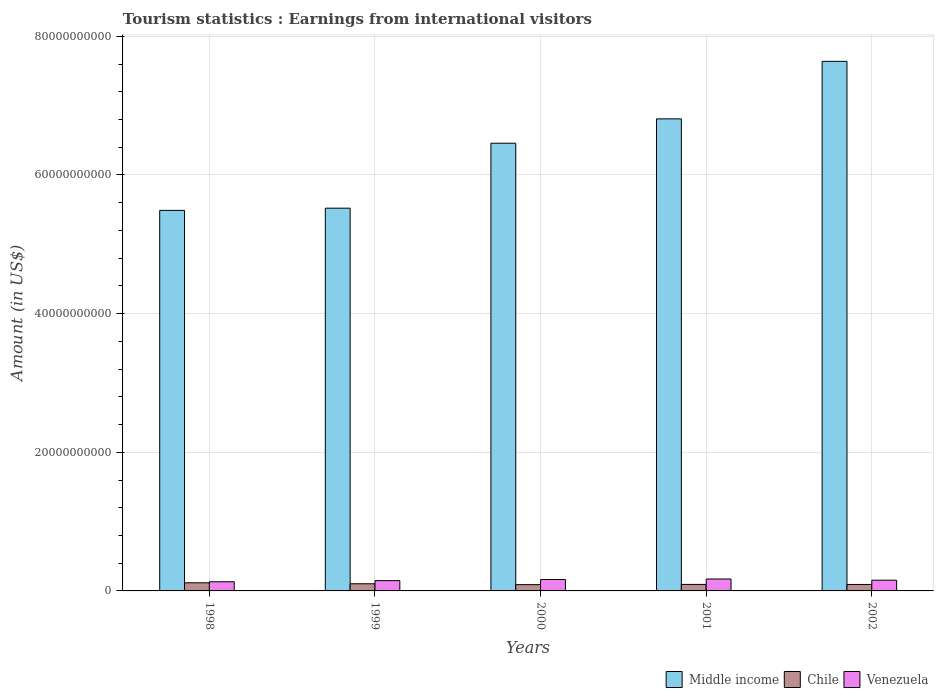How many different coloured bars are there?
Your answer should be compact. 3. How many groups of bars are there?
Offer a very short reply. 5. What is the label of the 5th group of bars from the left?
Offer a very short reply. 2002. What is the earnings from international visitors in Chile in 1999?
Your answer should be very brief. 1.03e+09. Across all years, what is the maximum earnings from international visitors in Middle income?
Your answer should be very brief. 7.64e+1. Across all years, what is the minimum earnings from international visitors in Middle income?
Your answer should be very brief. 5.49e+1. In which year was the earnings from international visitors in Venezuela maximum?
Provide a succinct answer. 2001. What is the total earnings from international visitors in Middle income in the graph?
Provide a short and direct response. 3.19e+11. What is the difference between the earnings from international visitors in Middle income in 2000 and that in 2002?
Give a very brief answer. -1.18e+1. What is the difference between the earnings from international visitors in Middle income in 2001 and the earnings from international visitors in Venezuela in 1999?
Give a very brief answer. 6.66e+1. What is the average earnings from international visitors in Chile per year?
Give a very brief answer. 9.96e+08. In the year 1999, what is the difference between the earnings from international visitors in Venezuela and earnings from international visitors in Middle income?
Your response must be concise. -5.37e+1. What is the ratio of the earnings from international visitors in Middle income in 1998 to that in 2002?
Provide a short and direct response. 0.72. What is the difference between the highest and the second highest earnings from international visitors in Chile?
Provide a short and direct response. 1.42e+08. What is the difference between the highest and the lowest earnings from international visitors in Chile?
Offer a terse response. 2.70e+08. What does the 3rd bar from the left in 2001 represents?
Provide a short and direct response. Venezuela. What does the 2nd bar from the right in 2000 represents?
Give a very brief answer. Chile. Is it the case that in every year, the sum of the earnings from international visitors in Venezuela and earnings from international visitors in Chile is greater than the earnings from international visitors in Middle income?
Provide a short and direct response. No. How many bars are there?
Your answer should be very brief. 15. Are all the bars in the graph horizontal?
Your answer should be compact. No. Are the values on the major ticks of Y-axis written in scientific E-notation?
Your response must be concise. No. Does the graph contain grids?
Your answer should be compact. Yes. Where does the legend appear in the graph?
Provide a succinct answer. Bottom right. What is the title of the graph?
Offer a terse response. Tourism statistics : Earnings from international visitors. Does "Middle East & North Africa (all income levels)" appear as one of the legend labels in the graph?
Give a very brief answer. No. What is the label or title of the X-axis?
Offer a very short reply. Years. What is the Amount (in US$) of Middle income in 1998?
Ensure brevity in your answer.  5.49e+1. What is the Amount (in US$) in Chile in 1998?
Your response must be concise. 1.17e+09. What is the Amount (in US$) of Venezuela in 1998?
Give a very brief answer. 1.32e+09. What is the Amount (in US$) in Middle income in 1999?
Provide a succinct answer. 5.52e+1. What is the Amount (in US$) of Chile in 1999?
Your answer should be compact. 1.03e+09. What is the Amount (in US$) in Venezuela in 1999?
Provide a short and direct response. 1.48e+09. What is the Amount (in US$) of Middle income in 2000?
Make the answer very short. 6.46e+1. What is the Amount (in US$) in Chile in 2000?
Offer a terse response. 9.04e+08. What is the Amount (in US$) in Venezuela in 2000?
Your answer should be very brief. 1.65e+09. What is the Amount (in US$) in Middle income in 2001?
Give a very brief answer. 6.81e+1. What is the Amount (in US$) in Chile in 2001?
Provide a succinct answer. 9.39e+08. What is the Amount (in US$) in Venezuela in 2001?
Your answer should be very brief. 1.72e+09. What is the Amount (in US$) in Middle income in 2002?
Provide a succinct answer. 7.64e+1. What is the Amount (in US$) in Chile in 2002?
Make the answer very short. 9.32e+08. What is the Amount (in US$) of Venezuela in 2002?
Provide a short and direct response. 1.55e+09. Across all years, what is the maximum Amount (in US$) of Middle income?
Give a very brief answer. 7.64e+1. Across all years, what is the maximum Amount (in US$) in Chile?
Keep it short and to the point. 1.17e+09. Across all years, what is the maximum Amount (in US$) in Venezuela?
Ensure brevity in your answer.  1.72e+09. Across all years, what is the minimum Amount (in US$) of Middle income?
Give a very brief answer. 5.49e+1. Across all years, what is the minimum Amount (in US$) of Chile?
Your answer should be compact. 9.04e+08. Across all years, what is the minimum Amount (in US$) of Venezuela?
Make the answer very short. 1.32e+09. What is the total Amount (in US$) of Middle income in the graph?
Make the answer very short. 3.19e+11. What is the total Amount (in US$) in Chile in the graph?
Keep it short and to the point. 4.98e+09. What is the total Amount (in US$) in Venezuela in the graph?
Keep it short and to the point. 7.71e+09. What is the difference between the Amount (in US$) of Middle income in 1998 and that in 1999?
Ensure brevity in your answer.  -3.18e+08. What is the difference between the Amount (in US$) in Chile in 1998 and that in 1999?
Your response must be concise. 1.42e+08. What is the difference between the Amount (in US$) in Venezuela in 1998 and that in 1999?
Provide a short and direct response. -1.64e+08. What is the difference between the Amount (in US$) in Middle income in 1998 and that in 2000?
Provide a succinct answer. -9.69e+09. What is the difference between the Amount (in US$) of Chile in 1998 and that in 2000?
Keep it short and to the point. 2.70e+08. What is the difference between the Amount (in US$) in Venezuela in 1998 and that in 2000?
Provide a short and direct response. -3.28e+08. What is the difference between the Amount (in US$) in Middle income in 1998 and that in 2001?
Provide a succinct answer. -1.32e+1. What is the difference between the Amount (in US$) in Chile in 1998 and that in 2001?
Offer a very short reply. 2.35e+08. What is the difference between the Amount (in US$) in Venezuela in 1998 and that in 2001?
Offer a very short reply. -3.99e+08. What is the difference between the Amount (in US$) in Middle income in 1998 and that in 2002?
Your answer should be compact. -2.15e+1. What is the difference between the Amount (in US$) of Chile in 1998 and that in 2002?
Make the answer very short. 2.42e+08. What is the difference between the Amount (in US$) in Venezuela in 1998 and that in 2002?
Keep it short and to the point. -2.27e+08. What is the difference between the Amount (in US$) in Middle income in 1999 and that in 2000?
Offer a very short reply. -9.37e+09. What is the difference between the Amount (in US$) of Chile in 1999 and that in 2000?
Your response must be concise. 1.28e+08. What is the difference between the Amount (in US$) in Venezuela in 1999 and that in 2000?
Provide a succinct answer. -1.64e+08. What is the difference between the Amount (in US$) in Middle income in 1999 and that in 2001?
Your answer should be very brief. -1.29e+1. What is the difference between the Amount (in US$) in Chile in 1999 and that in 2001?
Provide a succinct answer. 9.30e+07. What is the difference between the Amount (in US$) of Venezuela in 1999 and that in 2001?
Make the answer very short. -2.35e+08. What is the difference between the Amount (in US$) of Middle income in 1999 and that in 2002?
Keep it short and to the point. -2.12e+1. What is the difference between the Amount (in US$) of Chile in 1999 and that in 2002?
Your response must be concise. 1.00e+08. What is the difference between the Amount (in US$) in Venezuela in 1999 and that in 2002?
Your response must be concise. -6.30e+07. What is the difference between the Amount (in US$) in Middle income in 2000 and that in 2001?
Provide a short and direct response. -3.51e+09. What is the difference between the Amount (in US$) in Chile in 2000 and that in 2001?
Offer a terse response. -3.50e+07. What is the difference between the Amount (in US$) in Venezuela in 2000 and that in 2001?
Offer a very short reply. -7.10e+07. What is the difference between the Amount (in US$) in Middle income in 2000 and that in 2002?
Keep it short and to the point. -1.18e+1. What is the difference between the Amount (in US$) of Chile in 2000 and that in 2002?
Provide a succinct answer. -2.80e+07. What is the difference between the Amount (in US$) of Venezuela in 2000 and that in 2002?
Your answer should be compact. 1.01e+08. What is the difference between the Amount (in US$) in Middle income in 2001 and that in 2002?
Provide a short and direct response. -8.30e+09. What is the difference between the Amount (in US$) in Chile in 2001 and that in 2002?
Make the answer very short. 7.00e+06. What is the difference between the Amount (in US$) of Venezuela in 2001 and that in 2002?
Your response must be concise. 1.72e+08. What is the difference between the Amount (in US$) of Middle income in 1998 and the Amount (in US$) of Chile in 1999?
Give a very brief answer. 5.39e+1. What is the difference between the Amount (in US$) in Middle income in 1998 and the Amount (in US$) in Venezuela in 1999?
Keep it short and to the point. 5.34e+1. What is the difference between the Amount (in US$) of Chile in 1998 and the Amount (in US$) of Venezuela in 1999?
Your response must be concise. -3.09e+08. What is the difference between the Amount (in US$) of Middle income in 1998 and the Amount (in US$) of Chile in 2000?
Ensure brevity in your answer.  5.40e+1. What is the difference between the Amount (in US$) in Middle income in 1998 and the Amount (in US$) in Venezuela in 2000?
Offer a terse response. 5.32e+1. What is the difference between the Amount (in US$) in Chile in 1998 and the Amount (in US$) in Venezuela in 2000?
Your response must be concise. -4.73e+08. What is the difference between the Amount (in US$) of Middle income in 1998 and the Amount (in US$) of Chile in 2001?
Provide a succinct answer. 5.40e+1. What is the difference between the Amount (in US$) in Middle income in 1998 and the Amount (in US$) in Venezuela in 2001?
Ensure brevity in your answer.  5.32e+1. What is the difference between the Amount (in US$) in Chile in 1998 and the Amount (in US$) in Venezuela in 2001?
Give a very brief answer. -5.44e+08. What is the difference between the Amount (in US$) in Middle income in 1998 and the Amount (in US$) in Chile in 2002?
Provide a succinct answer. 5.40e+1. What is the difference between the Amount (in US$) of Middle income in 1998 and the Amount (in US$) of Venezuela in 2002?
Offer a very short reply. 5.33e+1. What is the difference between the Amount (in US$) in Chile in 1998 and the Amount (in US$) in Venezuela in 2002?
Offer a very short reply. -3.72e+08. What is the difference between the Amount (in US$) in Middle income in 1999 and the Amount (in US$) in Chile in 2000?
Provide a succinct answer. 5.43e+1. What is the difference between the Amount (in US$) of Middle income in 1999 and the Amount (in US$) of Venezuela in 2000?
Your answer should be very brief. 5.36e+1. What is the difference between the Amount (in US$) of Chile in 1999 and the Amount (in US$) of Venezuela in 2000?
Your answer should be compact. -6.15e+08. What is the difference between the Amount (in US$) in Middle income in 1999 and the Amount (in US$) in Chile in 2001?
Your answer should be very brief. 5.43e+1. What is the difference between the Amount (in US$) in Middle income in 1999 and the Amount (in US$) in Venezuela in 2001?
Your answer should be very brief. 5.35e+1. What is the difference between the Amount (in US$) of Chile in 1999 and the Amount (in US$) of Venezuela in 2001?
Give a very brief answer. -6.86e+08. What is the difference between the Amount (in US$) in Middle income in 1999 and the Amount (in US$) in Chile in 2002?
Your answer should be very brief. 5.43e+1. What is the difference between the Amount (in US$) in Middle income in 1999 and the Amount (in US$) in Venezuela in 2002?
Provide a short and direct response. 5.37e+1. What is the difference between the Amount (in US$) of Chile in 1999 and the Amount (in US$) of Venezuela in 2002?
Your response must be concise. -5.14e+08. What is the difference between the Amount (in US$) in Middle income in 2000 and the Amount (in US$) in Chile in 2001?
Your response must be concise. 6.36e+1. What is the difference between the Amount (in US$) in Middle income in 2000 and the Amount (in US$) in Venezuela in 2001?
Give a very brief answer. 6.29e+1. What is the difference between the Amount (in US$) of Chile in 2000 and the Amount (in US$) of Venezuela in 2001?
Your answer should be very brief. -8.14e+08. What is the difference between the Amount (in US$) in Middle income in 2000 and the Amount (in US$) in Chile in 2002?
Your answer should be compact. 6.36e+1. What is the difference between the Amount (in US$) in Middle income in 2000 and the Amount (in US$) in Venezuela in 2002?
Offer a terse response. 6.30e+1. What is the difference between the Amount (in US$) in Chile in 2000 and the Amount (in US$) in Venezuela in 2002?
Provide a short and direct response. -6.42e+08. What is the difference between the Amount (in US$) in Middle income in 2001 and the Amount (in US$) in Chile in 2002?
Your answer should be very brief. 6.72e+1. What is the difference between the Amount (in US$) in Middle income in 2001 and the Amount (in US$) in Venezuela in 2002?
Provide a short and direct response. 6.65e+1. What is the difference between the Amount (in US$) of Chile in 2001 and the Amount (in US$) of Venezuela in 2002?
Ensure brevity in your answer.  -6.07e+08. What is the average Amount (in US$) of Middle income per year?
Keep it short and to the point. 6.38e+1. What is the average Amount (in US$) of Chile per year?
Your answer should be compact. 9.96e+08. What is the average Amount (in US$) of Venezuela per year?
Give a very brief answer. 1.54e+09. In the year 1998, what is the difference between the Amount (in US$) of Middle income and Amount (in US$) of Chile?
Your response must be concise. 5.37e+1. In the year 1998, what is the difference between the Amount (in US$) in Middle income and Amount (in US$) in Venezuela?
Give a very brief answer. 5.36e+1. In the year 1998, what is the difference between the Amount (in US$) in Chile and Amount (in US$) in Venezuela?
Your response must be concise. -1.45e+08. In the year 1999, what is the difference between the Amount (in US$) of Middle income and Amount (in US$) of Chile?
Provide a short and direct response. 5.42e+1. In the year 1999, what is the difference between the Amount (in US$) of Middle income and Amount (in US$) of Venezuela?
Your response must be concise. 5.37e+1. In the year 1999, what is the difference between the Amount (in US$) in Chile and Amount (in US$) in Venezuela?
Offer a very short reply. -4.51e+08. In the year 2000, what is the difference between the Amount (in US$) in Middle income and Amount (in US$) in Chile?
Offer a terse response. 6.37e+1. In the year 2000, what is the difference between the Amount (in US$) in Middle income and Amount (in US$) in Venezuela?
Give a very brief answer. 6.29e+1. In the year 2000, what is the difference between the Amount (in US$) of Chile and Amount (in US$) of Venezuela?
Keep it short and to the point. -7.43e+08. In the year 2001, what is the difference between the Amount (in US$) of Middle income and Amount (in US$) of Chile?
Your answer should be very brief. 6.72e+1. In the year 2001, what is the difference between the Amount (in US$) of Middle income and Amount (in US$) of Venezuela?
Ensure brevity in your answer.  6.64e+1. In the year 2001, what is the difference between the Amount (in US$) in Chile and Amount (in US$) in Venezuela?
Your answer should be very brief. -7.79e+08. In the year 2002, what is the difference between the Amount (in US$) in Middle income and Amount (in US$) in Chile?
Ensure brevity in your answer.  7.55e+1. In the year 2002, what is the difference between the Amount (in US$) of Middle income and Amount (in US$) of Venezuela?
Offer a very short reply. 7.48e+1. In the year 2002, what is the difference between the Amount (in US$) of Chile and Amount (in US$) of Venezuela?
Your response must be concise. -6.14e+08. What is the ratio of the Amount (in US$) of Chile in 1998 to that in 1999?
Your answer should be very brief. 1.14. What is the ratio of the Amount (in US$) in Venezuela in 1998 to that in 1999?
Keep it short and to the point. 0.89. What is the ratio of the Amount (in US$) in Chile in 1998 to that in 2000?
Offer a very short reply. 1.3. What is the ratio of the Amount (in US$) in Venezuela in 1998 to that in 2000?
Provide a succinct answer. 0.8. What is the ratio of the Amount (in US$) in Middle income in 1998 to that in 2001?
Provide a short and direct response. 0.81. What is the ratio of the Amount (in US$) of Chile in 1998 to that in 2001?
Provide a short and direct response. 1.25. What is the ratio of the Amount (in US$) in Venezuela in 1998 to that in 2001?
Your answer should be very brief. 0.77. What is the ratio of the Amount (in US$) of Middle income in 1998 to that in 2002?
Your response must be concise. 0.72. What is the ratio of the Amount (in US$) of Chile in 1998 to that in 2002?
Your answer should be compact. 1.26. What is the ratio of the Amount (in US$) of Venezuela in 1998 to that in 2002?
Your answer should be very brief. 0.85. What is the ratio of the Amount (in US$) in Middle income in 1999 to that in 2000?
Offer a very short reply. 0.85. What is the ratio of the Amount (in US$) of Chile in 1999 to that in 2000?
Offer a terse response. 1.14. What is the ratio of the Amount (in US$) in Venezuela in 1999 to that in 2000?
Your response must be concise. 0.9. What is the ratio of the Amount (in US$) in Middle income in 1999 to that in 2001?
Offer a very short reply. 0.81. What is the ratio of the Amount (in US$) of Chile in 1999 to that in 2001?
Your response must be concise. 1.1. What is the ratio of the Amount (in US$) of Venezuela in 1999 to that in 2001?
Your answer should be very brief. 0.86. What is the ratio of the Amount (in US$) of Middle income in 1999 to that in 2002?
Keep it short and to the point. 0.72. What is the ratio of the Amount (in US$) in Chile in 1999 to that in 2002?
Offer a terse response. 1.11. What is the ratio of the Amount (in US$) in Venezuela in 1999 to that in 2002?
Your answer should be very brief. 0.96. What is the ratio of the Amount (in US$) of Middle income in 2000 to that in 2001?
Offer a very short reply. 0.95. What is the ratio of the Amount (in US$) in Chile in 2000 to that in 2001?
Your answer should be compact. 0.96. What is the ratio of the Amount (in US$) of Venezuela in 2000 to that in 2001?
Keep it short and to the point. 0.96. What is the ratio of the Amount (in US$) of Middle income in 2000 to that in 2002?
Keep it short and to the point. 0.85. What is the ratio of the Amount (in US$) in Chile in 2000 to that in 2002?
Your answer should be very brief. 0.97. What is the ratio of the Amount (in US$) in Venezuela in 2000 to that in 2002?
Your answer should be very brief. 1.07. What is the ratio of the Amount (in US$) of Middle income in 2001 to that in 2002?
Offer a very short reply. 0.89. What is the ratio of the Amount (in US$) of Chile in 2001 to that in 2002?
Your response must be concise. 1.01. What is the ratio of the Amount (in US$) of Venezuela in 2001 to that in 2002?
Offer a very short reply. 1.11. What is the difference between the highest and the second highest Amount (in US$) of Middle income?
Offer a terse response. 8.30e+09. What is the difference between the highest and the second highest Amount (in US$) of Chile?
Keep it short and to the point. 1.42e+08. What is the difference between the highest and the second highest Amount (in US$) of Venezuela?
Make the answer very short. 7.10e+07. What is the difference between the highest and the lowest Amount (in US$) of Middle income?
Keep it short and to the point. 2.15e+1. What is the difference between the highest and the lowest Amount (in US$) in Chile?
Offer a terse response. 2.70e+08. What is the difference between the highest and the lowest Amount (in US$) of Venezuela?
Provide a succinct answer. 3.99e+08. 